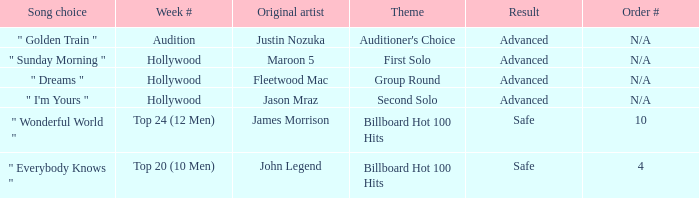What are all the results of songs is " golden train " Advanced. 